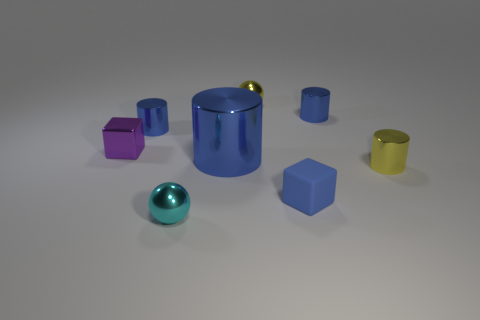How many blue cylinders must be subtracted to get 1 blue cylinders? 2 Subtract all green blocks. How many blue cylinders are left? 3 Subtract 1 cylinders. How many cylinders are left? 3 Add 2 tiny metal cubes. How many objects exist? 10 Subtract all cubes. How many objects are left? 6 Subtract all large spheres. Subtract all blue cylinders. How many objects are left? 5 Add 4 purple metallic blocks. How many purple metallic blocks are left? 5 Add 7 small metal spheres. How many small metal spheres exist? 9 Subtract 0 green spheres. How many objects are left? 8 